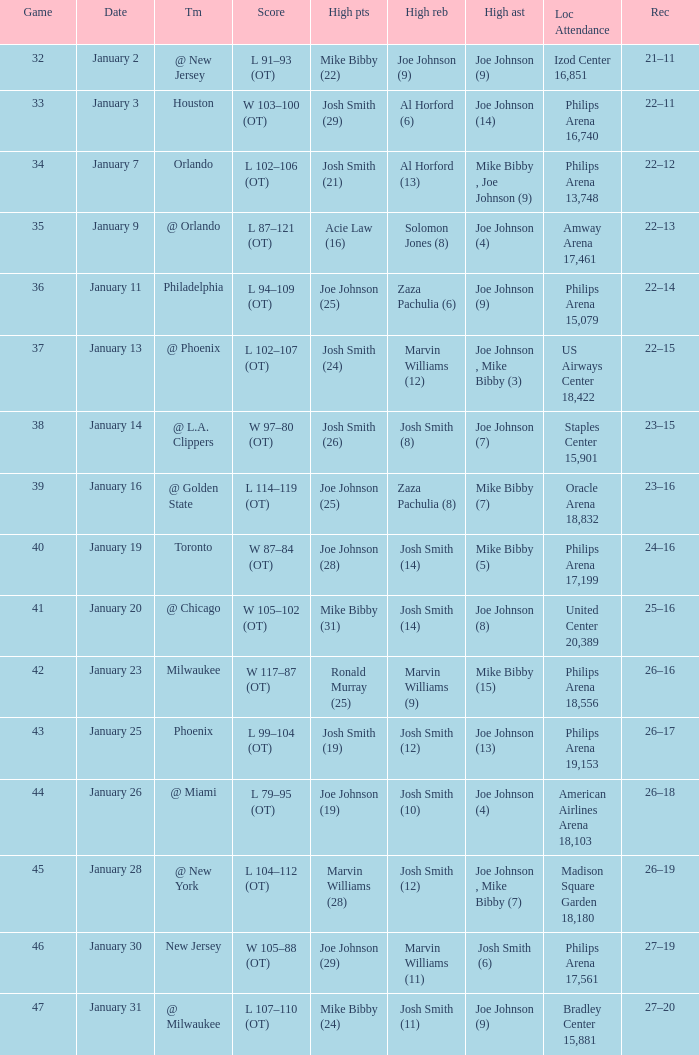What was the record after game 37? 22–15. 